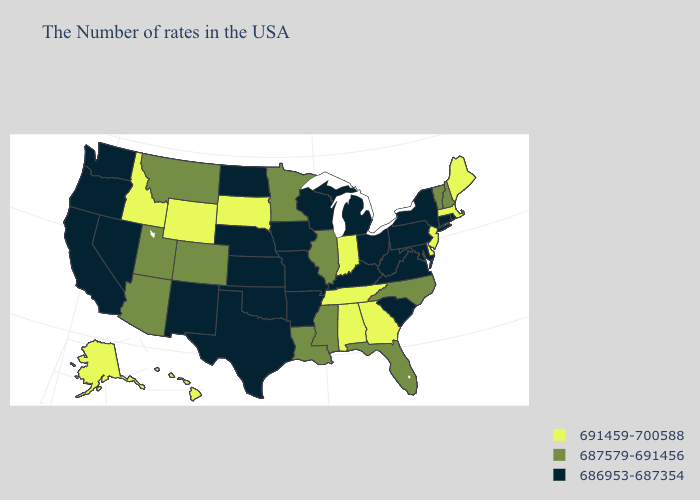What is the value of Louisiana?
Be succinct. 687579-691456. Name the states that have a value in the range 687579-691456?
Short answer required. New Hampshire, Vermont, North Carolina, Florida, Illinois, Mississippi, Louisiana, Minnesota, Colorado, Utah, Montana, Arizona. Name the states that have a value in the range 687579-691456?
Be succinct. New Hampshire, Vermont, North Carolina, Florida, Illinois, Mississippi, Louisiana, Minnesota, Colorado, Utah, Montana, Arizona. Does Virginia have the lowest value in the South?
Answer briefly. Yes. What is the highest value in the Northeast ?
Concise answer only. 691459-700588. Does the first symbol in the legend represent the smallest category?
Answer briefly. No. What is the lowest value in the USA?
Short answer required. 686953-687354. Is the legend a continuous bar?
Keep it brief. No. Name the states that have a value in the range 691459-700588?
Be succinct. Maine, Massachusetts, New Jersey, Delaware, Georgia, Indiana, Alabama, Tennessee, South Dakota, Wyoming, Idaho, Alaska, Hawaii. Name the states that have a value in the range 686953-687354?
Write a very short answer. Rhode Island, Connecticut, New York, Maryland, Pennsylvania, Virginia, South Carolina, West Virginia, Ohio, Michigan, Kentucky, Wisconsin, Missouri, Arkansas, Iowa, Kansas, Nebraska, Oklahoma, Texas, North Dakota, New Mexico, Nevada, California, Washington, Oregon. Name the states that have a value in the range 691459-700588?
Short answer required. Maine, Massachusetts, New Jersey, Delaware, Georgia, Indiana, Alabama, Tennessee, South Dakota, Wyoming, Idaho, Alaska, Hawaii. Name the states that have a value in the range 691459-700588?
Short answer required. Maine, Massachusetts, New Jersey, Delaware, Georgia, Indiana, Alabama, Tennessee, South Dakota, Wyoming, Idaho, Alaska, Hawaii. What is the highest value in the USA?
Keep it brief. 691459-700588. Does West Virginia have the highest value in the USA?
Quick response, please. No. How many symbols are there in the legend?
Short answer required. 3. 